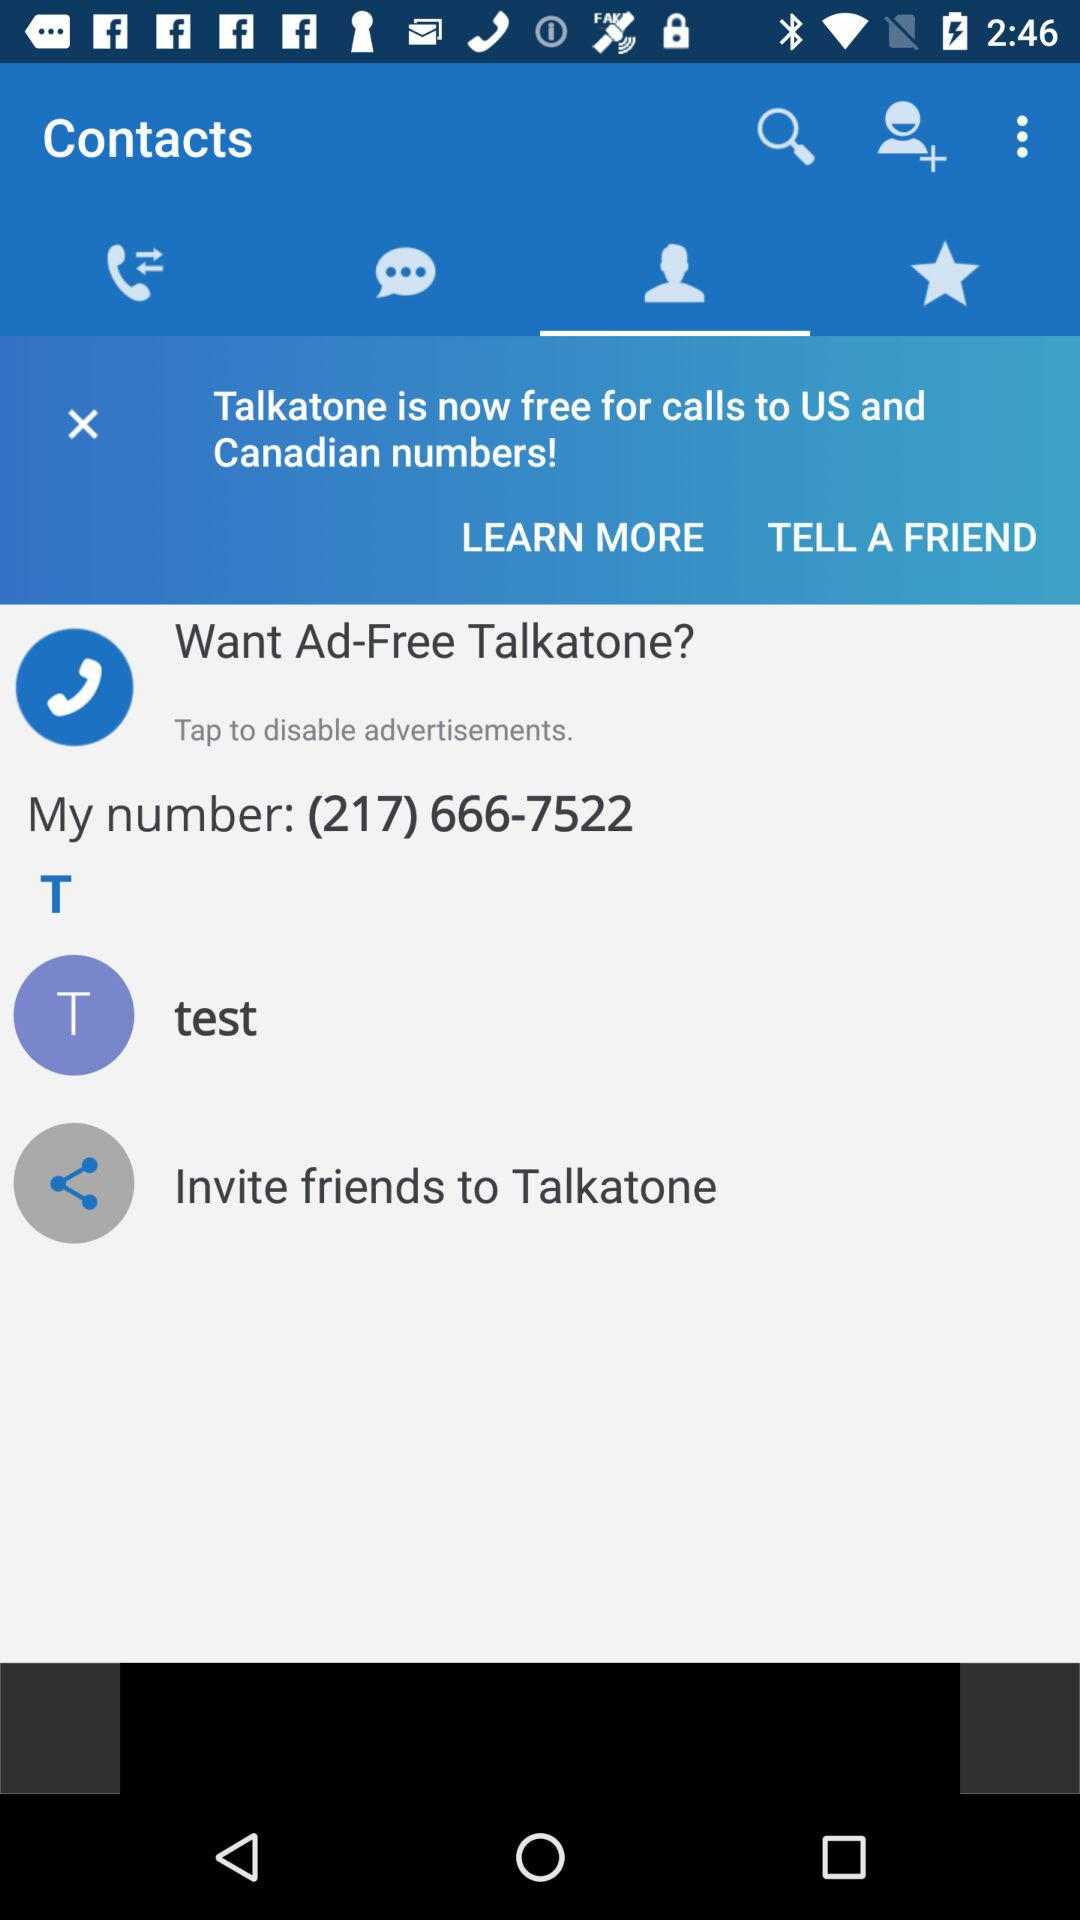What's the user number? The user number is (217) 666-7522. 